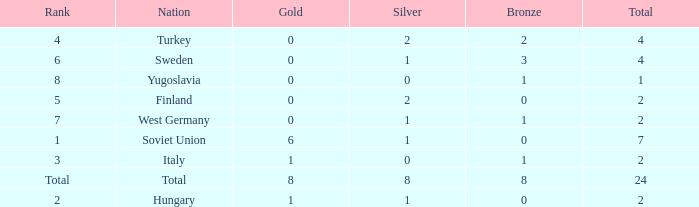What is the average Bronze, when Total is 7, and when Silver is greater than 1? None. 